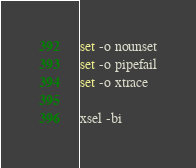<code> <loc_0><loc_0><loc_500><loc_500><_Bash_>set -o nounset
set -o pipefail
set -o xtrace

xsel -bi
</code> 